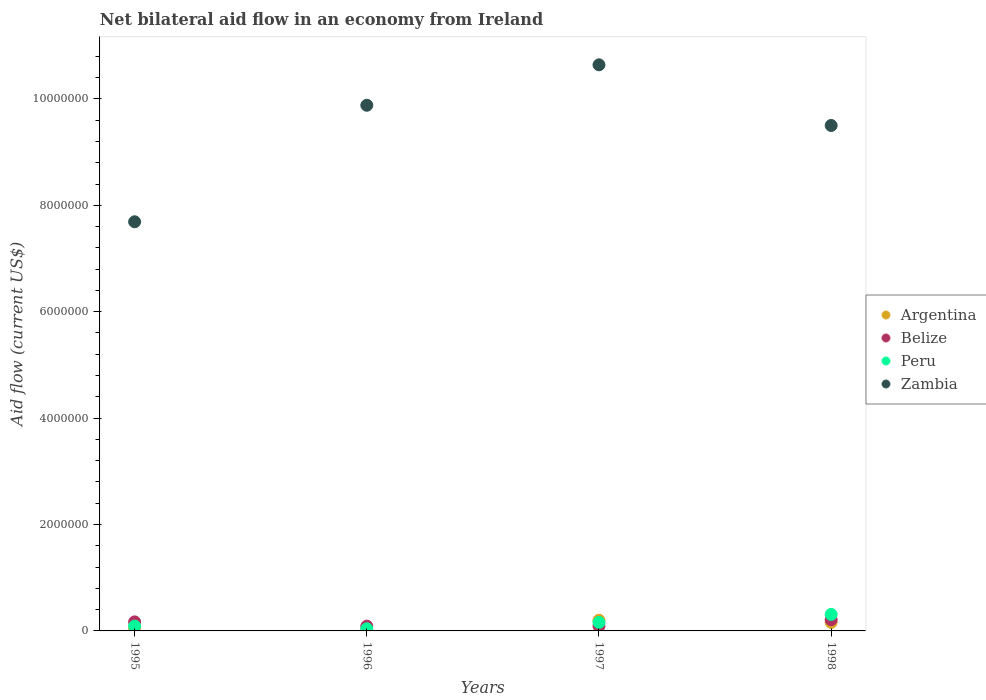Is the number of dotlines equal to the number of legend labels?
Offer a terse response. Yes. Across all years, what is the maximum net bilateral aid flow in Zambia?
Give a very brief answer. 1.06e+07. What is the total net bilateral aid flow in Argentina in the graph?
Keep it short and to the point. 4.20e+05. What is the difference between the net bilateral aid flow in Peru in 1995 and that in 1996?
Your answer should be compact. 5.00e+04. What is the difference between the net bilateral aid flow in Zambia in 1998 and the net bilateral aid flow in Belize in 1995?
Ensure brevity in your answer.  9.33e+06. In the year 1998, what is the difference between the net bilateral aid flow in Argentina and net bilateral aid flow in Peru?
Make the answer very short. -1.50e+05. What is the ratio of the net bilateral aid flow in Zambia in 1995 to that in 1997?
Offer a very short reply. 0.72. Is the net bilateral aid flow in Argentina in 1996 less than that in 1998?
Your response must be concise. Yes. Is the difference between the net bilateral aid flow in Argentina in 1996 and 1997 greater than the difference between the net bilateral aid flow in Peru in 1996 and 1997?
Give a very brief answer. No. What is the difference between the highest and the second highest net bilateral aid flow in Zambia?
Offer a very short reply. 7.60e+05. What is the difference between the highest and the lowest net bilateral aid flow in Zambia?
Provide a succinct answer. 2.95e+06. In how many years, is the net bilateral aid flow in Belize greater than the average net bilateral aid flow in Belize taken over all years?
Ensure brevity in your answer.  2. Is the sum of the net bilateral aid flow in Peru in 1995 and 1998 greater than the maximum net bilateral aid flow in Zambia across all years?
Your answer should be compact. No. Does the net bilateral aid flow in Argentina monotonically increase over the years?
Offer a very short reply. No. Is the net bilateral aid flow in Zambia strictly greater than the net bilateral aid flow in Argentina over the years?
Make the answer very short. Yes. How many years are there in the graph?
Ensure brevity in your answer.  4. How many legend labels are there?
Give a very brief answer. 4. How are the legend labels stacked?
Your answer should be very brief. Vertical. What is the title of the graph?
Offer a terse response. Net bilateral aid flow in an economy from Ireland. Does "Lao PDR" appear as one of the legend labels in the graph?
Your response must be concise. No. What is the label or title of the Y-axis?
Offer a very short reply. Aid flow (current US$). What is the Aid flow (current US$) of Peru in 1995?
Offer a very short reply. 9.00e+04. What is the Aid flow (current US$) in Zambia in 1995?
Ensure brevity in your answer.  7.69e+06. What is the Aid flow (current US$) in Belize in 1996?
Your answer should be compact. 9.00e+04. What is the Aid flow (current US$) in Zambia in 1996?
Your response must be concise. 9.88e+06. What is the Aid flow (current US$) in Argentina in 1997?
Make the answer very short. 2.00e+05. What is the Aid flow (current US$) in Belize in 1997?
Offer a terse response. 9.00e+04. What is the Aid flow (current US$) in Zambia in 1997?
Provide a succinct answer. 1.06e+07. What is the Aid flow (current US$) of Argentina in 1998?
Offer a very short reply. 1.60e+05. What is the Aid flow (current US$) of Belize in 1998?
Your answer should be very brief. 2.10e+05. What is the Aid flow (current US$) in Zambia in 1998?
Ensure brevity in your answer.  9.50e+06. Across all years, what is the maximum Aid flow (current US$) in Argentina?
Offer a terse response. 2.00e+05. Across all years, what is the maximum Aid flow (current US$) in Belize?
Offer a terse response. 2.10e+05. Across all years, what is the maximum Aid flow (current US$) in Zambia?
Keep it short and to the point. 1.06e+07. Across all years, what is the minimum Aid flow (current US$) in Argentina?
Offer a very short reply. 2.00e+04. Across all years, what is the minimum Aid flow (current US$) of Peru?
Keep it short and to the point. 4.00e+04. Across all years, what is the minimum Aid flow (current US$) in Zambia?
Your answer should be very brief. 7.69e+06. What is the total Aid flow (current US$) in Belize in the graph?
Your answer should be compact. 5.60e+05. What is the total Aid flow (current US$) in Zambia in the graph?
Keep it short and to the point. 3.77e+07. What is the difference between the Aid flow (current US$) of Belize in 1995 and that in 1996?
Offer a terse response. 8.00e+04. What is the difference between the Aid flow (current US$) in Peru in 1995 and that in 1996?
Provide a succinct answer. 5.00e+04. What is the difference between the Aid flow (current US$) of Zambia in 1995 and that in 1996?
Ensure brevity in your answer.  -2.19e+06. What is the difference between the Aid flow (current US$) in Zambia in 1995 and that in 1997?
Provide a short and direct response. -2.95e+06. What is the difference between the Aid flow (current US$) in Zambia in 1995 and that in 1998?
Provide a succinct answer. -1.81e+06. What is the difference between the Aid flow (current US$) in Peru in 1996 and that in 1997?
Keep it short and to the point. -1.20e+05. What is the difference between the Aid flow (current US$) in Zambia in 1996 and that in 1997?
Offer a terse response. -7.60e+05. What is the difference between the Aid flow (current US$) of Argentina in 1996 and that in 1998?
Offer a very short reply. -1.40e+05. What is the difference between the Aid flow (current US$) of Belize in 1996 and that in 1998?
Your answer should be very brief. -1.20e+05. What is the difference between the Aid flow (current US$) in Argentina in 1997 and that in 1998?
Your response must be concise. 4.00e+04. What is the difference between the Aid flow (current US$) in Zambia in 1997 and that in 1998?
Make the answer very short. 1.14e+06. What is the difference between the Aid flow (current US$) of Argentina in 1995 and the Aid flow (current US$) of Belize in 1996?
Make the answer very short. -5.00e+04. What is the difference between the Aid flow (current US$) of Argentina in 1995 and the Aid flow (current US$) of Peru in 1996?
Keep it short and to the point. 0. What is the difference between the Aid flow (current US$) of Argentina in 1995 and the Aid flow (current US$) of Zambia in 1996?
Offer a very short reply. -9.84e+06. What is the difference between the Aid flow (current US$) in Belize in 1995 and the Aid flow (current US$) in Zambia in 1996?
Your response must be concise. -9.71e+06. What is the difference between the Aid flow (current US$) in Peru in 1995 and the Aid flow (current US$) in Zambia in 1996?
Offer a very short reply. -9.79e+06. What is the difference between the Aid flow (current US$) of Argentina in 1995 and the Aid flow (current US$) of Peru in 1997?
Provide a succinct answer. -1.20e+05. What is the difference between the Aid flow (current US$) of Argentina in 1995 and the Aid flow (current US$) of Zambia in 1997?
Your answer should be compact. -1.06e+07. What is the difference between the Aid flow (current US$) in Belize in 1995 and the Aid flow (current US$) in Zambia in 1997?
Your answer should be very brief. -1.05e+07. What is the difference between the Aid flow (current US$) in Peru in 1995 and the Aid flow (current US$) in Zambia in 1997?
Your answer should be compact. -1.06e+07. What is the difference between the Aid flow (current US$) of Argentina in 1995 and the Aid flow (current US$) of Belize in 1998?
Your response must be concise. -1.70e+05. What is the difference between the Aid flow (current US$) in Argentina in 1995 and the Aid flow (current US$) in Peru in 1998?
Make the answer very short. -2.70e+05. What is the difference between the Aid flow (current US$) of Argentina in 1995 and the Aid flow (current US$) of Zambia in 1998?
Give a very brief answer. -9.46e+06. What is the difference between the Aid flow (current US$) of Belize in 1995 and the Aid flow (current US$) of Zambia in 1998?
Offer a very short reply. -9.33e+06. What is the difference between the Aid flow (current US$) in Peru in 1995 and the Aid flow (current US$) in Zambia in 1998?
Your answer should be compact. -9.41e+06. What is the difference between the Aid flow (current US$) in Argentina in 1996 and the Aid flow (current US$) in Peru in 1997?
Make the answer very short. -1.40e+05. What is the difference between the Aid flow (current US$) of Argentina in 1996 and the Aid flow (current US$) of Zambia in 1997?
Ensure brevity in your answer.  -1.06e+07. What is the difference between the Aid flow (current US$) in Belize in 1996 and the Aid flow (current US$) in Zambia in 1997?
Give a very brief answer. -1.06e+07. What is the difference between the Aid flow (current US$) of Peru in 1996 and the Aid flow (current US$) of Zambia in 1997?
Keep it short and to the point. -1.06e+07. What is the difference between the Aid flow (current US$) of Argentina in 1996 and the Aid flow (current US$) of Peru in 1998?
Provide a short and direct response. -2.90e+05. What is the difference between the Aid flow (current US$) in Argentina in 1996 and the Aid flow (current US$) in Zambia in 1998?
Keep it short and to the point. -9.48e+06. What is the difference between the Aid flow (current US$) of Belize in 1996 and the Aid flow (current US$) of Zambia in 1998?
Give a very brief answer. -9.41e+06. What is the difference between the Aid flow (current US$) in Peru in 1996 and the Aid flow (current US$) in Zambia in 1998?
Keep it short and to the point. -9.46e+06. What is the difference between the Aid flow (current US$) in Argentina in 1997 and the Aid flow (current US$) in Belize in 1998?
Your response must be concise. -10000. What is the difference between the Aid flow (current US$) in Argentina in 1997 and the Aid flow (current US$) in Zambia in 1998?
Offer a very short reply. -9.30e+06. What is the difference between the Aid flow (current US$) in Belize in 1997 and the Aid flow (current US$) in Peru in 1998?
Give a very brief answer. -2.20e+05. What is the difference between the Aid flow (current US$) of Belize in 1997 and the Aid flow (current US$) of Zambia in 1998?
Provide a succinct answer. -9.41e+06. What is the difference between the Aid flow (current US$) in Peru in 1997 and the Aid flow (current US$) in Zambia in 1998?
Your response must be concise. -9.34e+06. What is the average Aid flow (current US$) in Argentina per year?
Your answer should be compact. 1.05e+05. What is the average Aid flow (current US$) of Belize per year?
Keep it short and to the point. 1.40e+05. What is the average Aid flow (current US$) of Zambia per year?
Offer a terse response. 9.43e+06. In the year 1995, what is the difference between the Aid flow (current US$) of Argentina and Aid flow (current US$) of Belize?
Give a very brief answer. -1.30e+05. In the year 1995, what is the difference between the Aid flow (current US$) in Argentina and Aid flow (current US$) in Zambia?
Provide a succinct answer. -7.65e+06. In the year 1995, what is the difference between the Aid flow (current US$) of Belize and Aid flow (current US$) of Peru?
Provide a succinct answer. 8.00e+04. In the year 1995, what is the difference between the Aid flow (current US$) of Belize and Aid flow (current US$) of Zambia?
Provide a succinct answer. -7.52e+06. In the year 1995, what is the difference between the Aid flow (current US$) of Peru and Aid flow (current US$) of Zambia?
Provide a succinct answer. -7.60e+06. In the year 1996, what is the difference between the Aid flow (current US$) in Argentina and Aid flow (current US$) in Belize?
Give a very brief answer. -7.00e+04. In the year 1996, what is the difference between the Aid flow (current US$) in Argentina and Aid flow (current US$) in Peru?
Offer a very short reply. -2.00e+04. In the year 1996, what is the difference between the Aid flow (current US$) in Argentina and Aid flow (current US$) in Zambia?
Give a very brief answer. -9.86e+06. In the year 1996, what is the difference between the Aid flow (current US$) in Belize and Aid flow (current US$) in Peru?
Offer a terse response. 5.00e+04. In the year 1996, what is the difference between the Aid flow (current US$) in Belize and Aid flow (current US$) in Zambia?
Give a very brief answer. -9.79e+06. In the year 1996, what is the difference between the Aid flow (current US$) in Peru and Aid flow (current US$) in Zambia?
Ensure brevity in your answer.  -9.84e+06. In the year 1997, what is the difference between the Aid flow (current US$) of Argentina and Aid flow (current US$) of Peru?
Offer a very short reply. 4.00e+04. In the year 1997, what is the difference between the Aid flow (current US$) of Argentina and Aid flow (current US$) of Zambia?
Provide a succinct answer. -1.04e+07. In the year 1997, what is the difference between the Aid flow (current US$) of Belize and Aid flow (current US$) of Zambia?
Offer a very short reply. -1.06e+07. In the year 1997, what is the difference between the Aid flow (current US$) of Peru and Aid flow (current US$) of Zambia?
Your answer should be very brief. -1.05e+07. In the year 1998, what is the difference between the Aid flow (current US$) in Argentina and Aid flow (current US$) in Belize?
Make the answer very short. -5.00e+04. In the year 1998, what is the difference between the Aid flow (current US$) of Argentina and Aid flow (current US$) of Zambia?
Ensure brevity in your answer.  -9.34e+06. In the year 1998, what is the difference between the Aid flow (current US$) of Belize and Aid flow (current US$) of Peru?
Provide a succinct answer. -1.00e+05. In the year 1998, what is the difference between the Aid flow (current US$) of Belize and Aid flow (current US$) of Zambia?
Your answer should be very brief. -9.29e+06. In the year 1998, what is the difference between the Aid flow (current US$) of Peru and Aid flow (current US$) of Zambia?
Your answer should be compact. -9.19e+06. What is the ratio of the Aid flow (current US$) of Argentina in 1995 to that in 1996?
Offer a terse response. 2. What is the ratio of the Aid flow (current US$) of Belize in 1995 to that in 1996?
Offer a very short reply. 1.89. What is the ratio of the Aid flow (current US$) of Peru in 1995 to that in 1996?
Your response must be concise. 2.25. What is the ratio of the Aid flow (current US$) of Zambia in 1995 to that in 1996?
Provide a succinct answer. 0.78. What is the ratio of the Aid flow (current US$) in Argentina in 1995 to that in 1997?
Give a very brief answer. 0.2. What is the ratio of the Aid flow (current US$) in Belize in 1995 to that in 1997?
Keep it short and to the point. 1.89. What is the ratio of the Aid flow (current US$) of Peru in 1995 to that in 1997?
Your answer should be very brief. 0.56. What is the ratio of the Aid flow (current US$) of Zambia in 1995 to that in 1997?
Provide a succinct answer. 0.72. What is the ratio of the Aid flow (current US$) of Belize in 1995 to that in 1998?
Make the answer very short. 0.81. What is the ratio of the Aid flow (current US$) of Peru in 1995 to that in 1998?
Your response must be concise. 0.29. What is the ratio of the Aid flow (current US$) of Zambia in 1995 to that in 1998?
Your answer should be very brief. 0.81. What is the ratio of the Aid flow (current US$) of Peru in 1996 to that in 1997?
Keep it short and to the point. 0.25. What is the ratio of the Aid flow (current US$) of Zambia in 1996 to that in 1997?
Make the answer very short. 0.93. What is the ratio of the Aid flow (current US$) of Argentina in 1996 to that in 1998?
Your answer should be compact. 0.12. What is the ratio of the Aid flow (current US$) of Belize in 1996 to that in 1998?
Provide a short and direct response. 0.43. What is the ratio of the Aid flow (current US$) in Peru in 1996 to that in 1998?
Offer a very short reply. 0.13. What is the ratio of the Aid flow (current US$) in Zambia in 1996 to that in 1998?
Provide a short and direct response. 1.04. What is the ratio of the Aid flow (current US$) in Belize in 1997 to that in 1998?
Provide a short and direct response. 0.43. What is the ratio of the Aid flow (current US$) of Peru in 1997 to that in 1998?
Keep it short and to the point. 0.52. What is the ratio of the Aid flow (current US$) of Zambia in 1997 to that in 1998?
Ensure brevity in your answer.  1.12. What is the difference between the highest and the second highest Aid flow (current US$) in Belize?
Make the answer very short. 4.00e+04. What is the difference between the highest and the second highest Aid flow (current US$) in Zambia?
Your response must be concise. 7.60e+05. What is the difference between the highest and the lowest Aid flow (current US$) in Argentina?
Offer a terse response. 1.80e+05. What is the difference between the highest and the lowest Aid flow (current US$) of Peru?
Make the answer very short. 2.70e+05. What is the difference between the highest and the lowest Aid flow (current US$) in Zambia?
Offer a very short reply. 2.95e+06. 